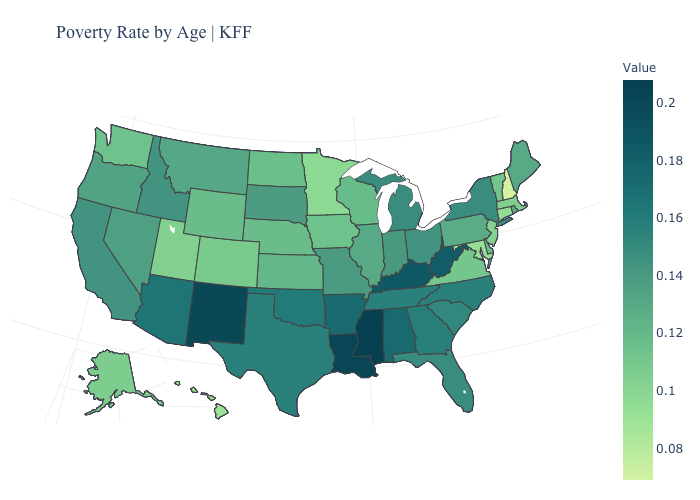Does New York have the highest value in the Northeast?
Be succinct. Yes. Which states hav the highest value in the MidWest?
Keep it brief. Michigan. Among the states that border Arkansas , which have the lowest value?
Write a very short answer. Missouri. Is the legend a continuous bar?
Concise answer only. Yes. Which states have the lowest value in the USA?
Answer briefly. New Hampshire. Is the legend a continuous bar?
Answer briefly. Yes. Does Georgia have a higher value than New Mexico?
Quick response, please. No. Which states have the lowest value in the USA?
Concise answer only. New Hampshire. 